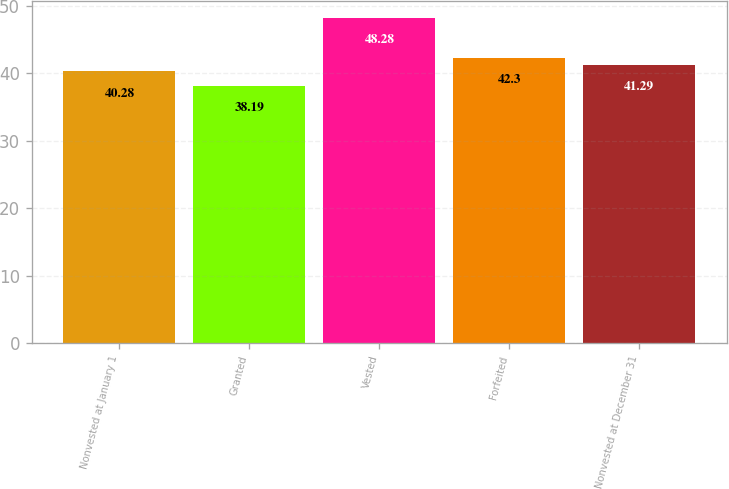Convert chart. <chart><loc_0><loc_0><loc_500><loc_500><bar_chart><fcel>Nonvested at January 1<fcel>Granted<fcel>Vested<fcel>Forfeited<fcel>Nonvested at December 31<nl><fcel>40.28<fcel>38.19<fcel>48.28<fcel>42.3<fcel>41.29<nl></chart> 